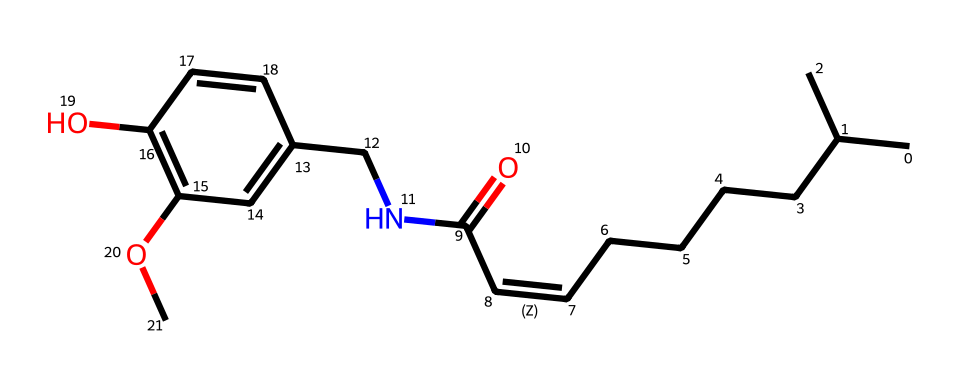how many carbon atoms are in the structure? Counting the carbon (C) atoms in the SMILES representation indicates there are a total of 15 carbon atoms present in the structure.
Answer: 15 what is the primary functional group present in capsaicin? Analyzing the SMILES structure, the presence of a carboxamide group (C(=O)N) indicates that the primary functional group is an amide.
Answer: amide does capsaicin contain any aromatic rings? Looking at the structure, we can observe a benzene-derived structure (the presence of alternating double bonds) indicates that yes, capsaicin contains an aromatic ring.
Answer: yes what characteristic does capsaicin impart to food? The structure shows it contains a long aliphatic chain and aromatic components, which indicates that it imparts a spicy sensation to food.
Answer: spiciness which atom in the structure is responsible for the pungent taste? The nitrogen atom (N) in the carboxamide group is specifically related to the pungent taste sensation attributed to capsaicin.
Answer: nitrogen 